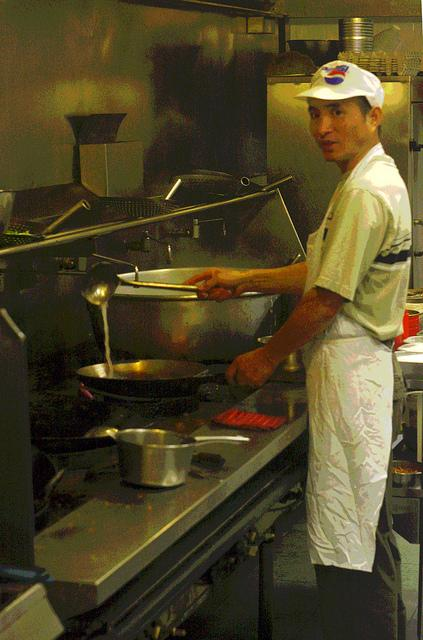What style food is most likely being prepared in this kitchen?

Choices:
A) baked goods
B) mexican
C) italian
D) chinese chinese 